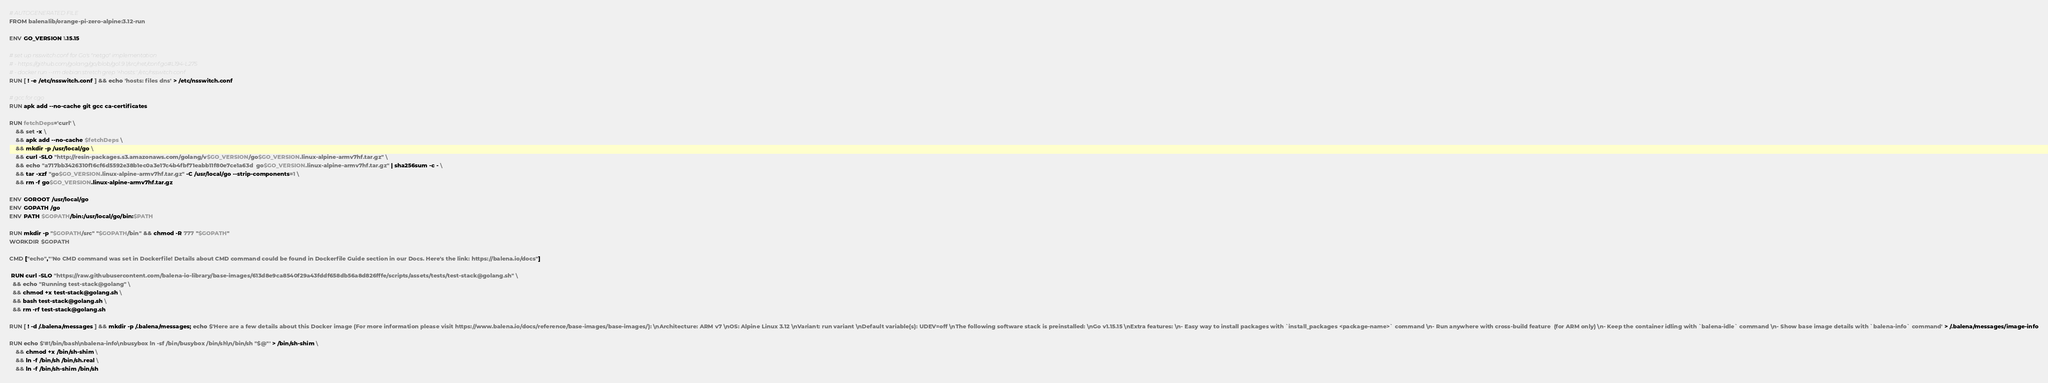<code> <loc_0><loc_0><loc_500><loc_500><_Dockerfile_># AUTOGENERATED FILE
FROM balenalib/orange-pi-zero-alpine:3.12-run

ENV GO_VERSION 1.15.15

# set up nsswitch.conf for Go's "netgo" implementation
# - https://github.com/golang/go/blob/go1.9.1/src/net/conf.go#L194-L275
# - docker run --rm debian:stretch grep '^hosts:' /etc/nsswitch.conf
RUN [ ! -e /etc/nsswitch.conf ] && echo 'hosts: files dns' > /etc/nsswitch.conf

# gcc for cgo
RUN apk add --no-cache git gcc ca-certificates

RUN fetchDeps='curl' \
	&& set -x \
	&& apk add --no-cache $fetchDeps \
	&& mkdir -p /usr/local/go \
	&& curl -SLO "http://resin-packages.s3.amazonaws.com/golang/v$GO_VERSION/go$GO_VERSION.linux-alpine-armv7hf.tar.gz" \
	&& echo "a717bb3426310f16cf6d5592e38b1ec0a3e17c4b4fbf71eabb11f80e7ce1a63d  go$GO_VERSION.linux-alpine-armv7hf.tar.gz" | sha256sum -c - \
	&& tar -xzf "go$GO_VERSION.linux-alpine-armv7hf.tar.gz" -C /usr/local/go --strip-components=1 \
	&& rm -f go$GO_VERSION.linux-alpine-armv7hf.tar.gz

ENV GOROOT /usr/local/go
ENV GOPATH /go
ENV PATH $GOPATH/bin:/usr/local/go/bin:$PATH

RUN mkdir -p "$GOPATH/src" "$GOPATH/bin" && chmod -R 777 "$GOPATH"
WORKDIR $GOPATH

CMD ["echo","'No CMD command was set in Dockerfile! Details about CMD command could be found in Dockerfile Guide section in our Docs. Here's the link: https://balena.io/docs"]

 RUN curl -SLO "https://raw.githubusercontent.com/balena-io-library/base-images/613d8e9ca8540f29a43fddf658db56a8d826fffe/scripts/assets/tests/test-stack@golang.sh" \
  && echo "Running test-stack@golang" \
  && chmod +x test-stack@golang.sh \
  && bash test-stack@golang.sh \
  && rm -rf test-stack@golang.sh 

RUN [ ! -d /.balena/messages ] && mkdir -p /.balena/messages; echo $'Here are a few details about this Docker image (For more information please visit https://www.balena.io/docs/reference/base-images/base-images/): \nArchitecture: ARM v7 \nOS: Alpine Linux 3.12 \nVariant: run variant \nDefault variable(s): UDEV=off \nThe following software stack is preinstalled: \nGo v1.15.15 \nExtra features: \n- Easy way to install packages with `install_packages <package-name>` command \n- Run anywhere with cross-build feature  (for ARM only) \n- Keep the container idling with `balena-idle` command \n- Show base image details with `balena-info` command' > /.balena/messages/image-info

RUN echo $'#!/bin/bash\nbalena-info\nbusybox ln -sf /bin/busybox /bin/sh\n/bin/sh "$@"' > /bin/sh-shim \
	&& chmod +x /bin/sh-shim \
	&& ln -f /bin/sh /bin/sh.real \
	&& ln -f /bin/sh-shim /bin/sh</code> 